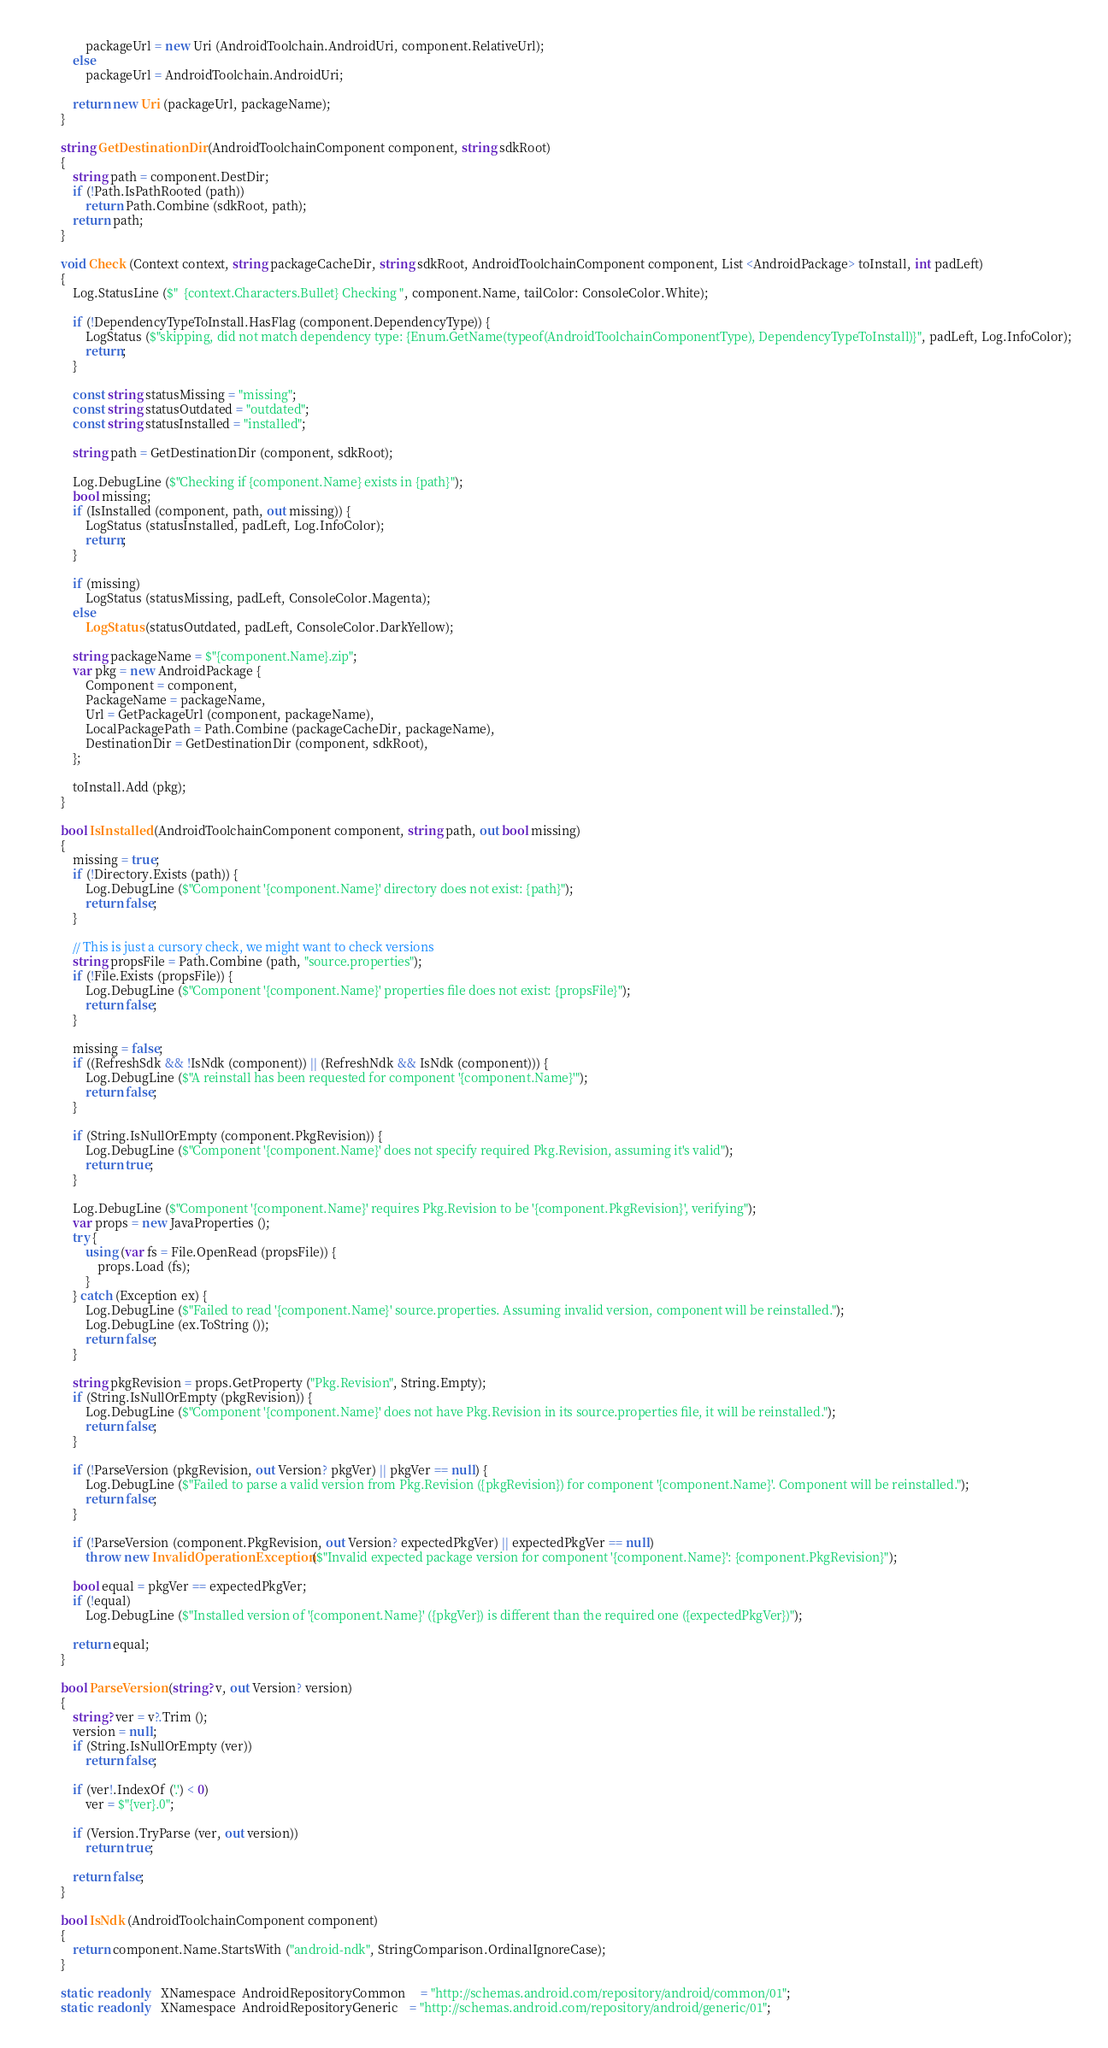Convert code to text. <code><loc_0><loc_0><loc_500><loc_500><_C#_>				packageUrl = new Uri (AndroidToolchain.AndroidUri, component.RelativeUrl);
			else
				packageUrl = AndroidToolchain.AndroidUri;

			return new Uri (packageUrl, packageName);
		}

		string GetDestinationDir (AndroidToolchainComponent component, string sdkRoot)
		{
			string path = component.DestDir;
			if (!Path.IsPathRooted (path))
				return Path.Combine (sdkRoot, path);
			return path;
		}

		void Check (Context context, string packageCacheDir, string sdkRoot, AndroidToolchainComponent component, List <AndroidPackage> toInstall, int padLeft)
		{
			Log.StatusLine ($"  {context.Characters.Bullet} Checking ", component.Name, tailColor: ConsoleColor.White);

			if (!DependencyTypeToInstall.HasFlag (component.DependencyType)) {
				LogStatus ($"skipping, did not match dependency type: {Enum.GetName(typeof(AndroidToolchainComponentType), DependencyTypeToInstall)}", padLeft, Log.InfoColor);
				return;
			}

			const string statusMissing = "missing";
			const string statusOutdated = "outdated";
			const string statusInstalled = "installed";

			string path = GetDestinationDir (component, sdkRoot);

			Log.DebugLine ($"Checking if {component.Name} exists in {path}");
			bool missing;
			if (IsInstalled (component, path, out missing)) {
				LogStatus (statusInstalled, padLeft, Log.InfoColor);
				return;
			}

			if (missing)
				LogStatus (statusMissing, padLeft, ConsoleColor.Magenta);
			else
				LogStatus (statusOutdated, padLeft, ConsoleColor.DarkYellow);

			string packageName = $"{component.Name}.zip";
			var pkg = new AndroidPackage {
				Component = component,
				PackageName = packageName,
				Url = GetPackageUrl (component, packageName),
				LocalPackagePath = Path.Combine (packageCacheDir, packageName),
				DestinationDir = GetDestinationDir (component, sdkRoot),
			};

			toInstall.Add (pkg);
		}

		bool IsInstalled (AndroidToolchainComponent component, string path, out bool missing)
		{
			missing = true;
			if (!Directory.Exists (path)) {
				Log.DebugLine ($"Component '{component.Name}' directory does not exist: {path}");
				return false;
			}

			// This is just a cursory check, we might want to check versions
			string propsFile = Path.Combine (path, "source.properties");
			if (!File.Exists (propsFile)) {
				Log.DebugLine ($"Component '{component.Name}' properties file does not exist: {propsFile}");
				return false;
			}

			missing = false;
			if ((RefreshSdk && !IsNdk (component)) || (RefreshNdk && IsNdk (component))) {
				Log.DebugLine ($"A reinstall has been requested for component '{component.Name}'");
				return false;
			}

			if (String.IsNullOrEmpty (component.PkgRevision)) {
				Log.DebugLine ($"Component '{component.Name}' does not specify required Pkg.Revision, assuming it's valid");
				return true;
			}

			Log.DebugLine ($"Component '{component.Name}' requires Pkg.Revision to be '{component.PkgRevision}', verifying");
			var props = new JavaProperties ();
			try {
				using (var fs = File.OpenRead (propsFile)) {
					props.Load (fs);
				}
			} catch (Exception ex) {
				Log.DebugLine ($"Failed to read '{component.Name}' source.properties. Assuming invalid version, component will be reinstalled.");
				Log.DebugLine (ex.ToString ());
				return false;
			}

			string pkgRevision = props.GetProperty ("Pkg.Revision", String.Empty);
			if (String.IsNullOrEmpty (pkgRevision)) {
				Log.DebugLine ($"Component '{component.Name}' does not have Pkg.Revision in its source.properties file, it will be reinstalled.");
				return false;
			}

			if (!ParseVersion (pkgRevision, out Version? pkgVer) || pkgVer == null) {
				Log.DebugLine ($"Failed to parse a valid version from Pkg.Revision ({pkgRevision}) for component '{component.Name}'. Component will be reinstalled.");
				return false;
			}

			if (!ParseVersion (component.PkgRevision, out Version? expectedPkgVer) || expectedPkgVer == null)
				throw new InvalidOperationException ($"Invalid expected package version for component '{component.Name}': {component.PkgRevision}");

			bool equal = pkgVer == expectedPkgVer;
			if (!equal)
				Log.DebugLine ($"Installed version of '{component.Name}' ({pkgVer}) is different than the required one ({expectedPkgVer})");

			return equal;
		}

		bool ParseVersion (string? v, out Version? version)
		{
			string? ver = v?.Trim ();
			version = null;
			if (String.IsNullOrEmpty (ver))
				return false;

			if (ver!.IndexOf ('.') < 0)
				ver = $"{ver}.0";

			if (Version.TryParse (ver, out version))
				return true;

			return false;
		}

		bool IsNdk (AndroidToolchainComponent component)
		{
			return component.Name.StartsWith ("android-ndk", StringComparison.OrdinalIgnoreCase);
		}

		static  readonly    XNamespace  AndroidRepositoryCommon     = "http://schemas.android.com/repository/android/common/01";
		static  readonly    XNamespace  AndroidRepositoryGeneric    = "http://schemas.android.com/repository/android/generic/01";
</code> 